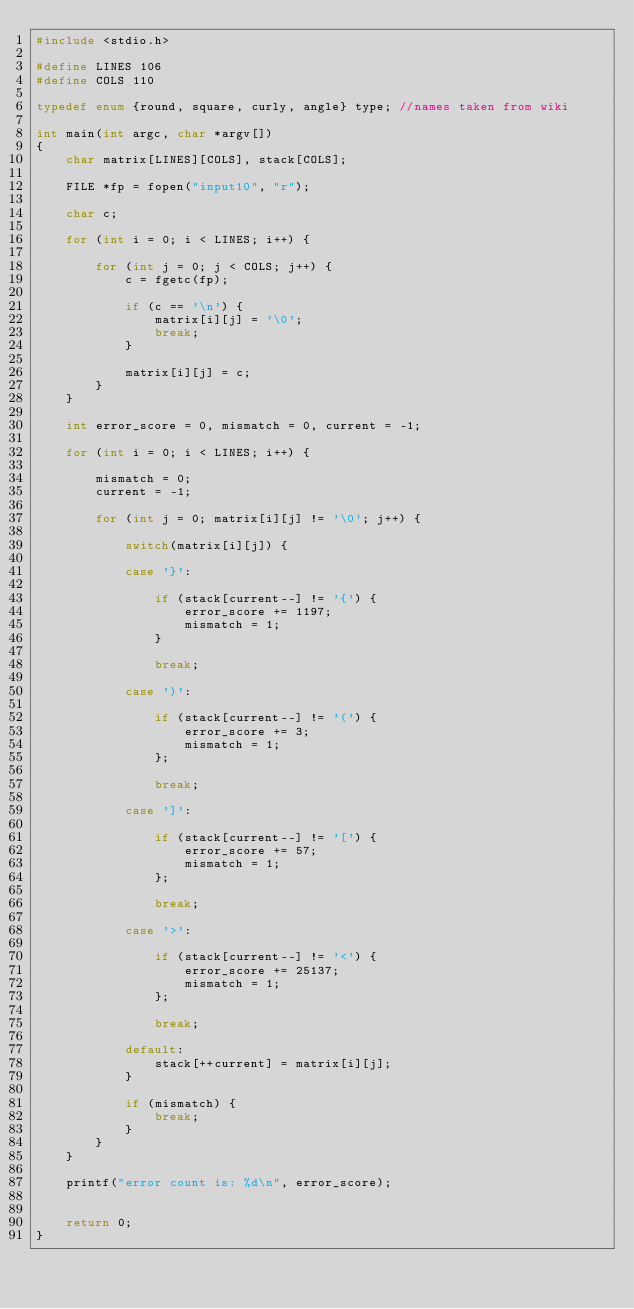<code> <loc_0><loc_0><loc_500><loc_500><_C_>#include <stdio.h>

#define LINES 106
#define COLS 110

typedef enum {round, square, curly, angle} type; //names taken from wiki

int main(int argc, char *argv[])
{
    char matrix[LINES][COLS], stack[COLS];

    FILE *fp = fopen("input10", "r");

    char c;

    for (int i = 0; i < LINES; i++) {

        for (int j = 0; j < COLS; j++) {
            c = fgetc(fp);

            if (c == '\n') {
                matrix[i][j] = '\0';
                break;
            }

            matrix[i][j] = c;
        }
    }

    int error_score = 0, mismatch = 0, current = -1;

    for (int i = 0; i < LINES; i++) {

        mismatch = 0;
        current = -1;

        for (int j = 0; matrix[i][j] != '\0'; j++) {

            switch(matrix[i][j]) {

            case '}':

                if (stack[current--] != '{') {
                    error_score += 1197;
                    mismatch = 1;
                }

                break;

            case ')':

                if (stack[current--] != '(') {
                    error_score += 3;
                    mismatch = 1;
                };

                break;

            case ']':

                if (stack[current--] != '[') {
                    error_score += 57;
                    mismatch = 1;
                };

                break;

            case '>':

                if (stack[current--] != '<') {
                    error_score += 25137;
                    mismatch = 1;
                };

                break;

            default:
                stack[++current] = matrix[i][j];
            }

            if (mismatch) {
                break;
            }
        }
    }

    printf("error count is: %d\n", error_score);


    return 0;
}
</code> 